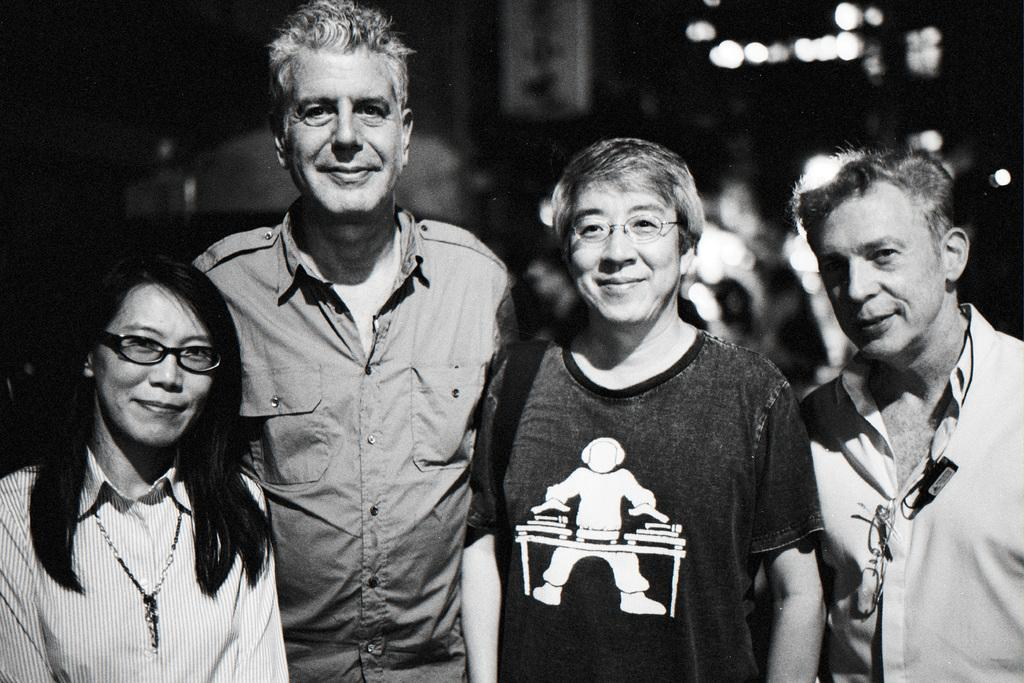What is the color scheme of the image? The image is black and white. How many men and women are in the image? There are two men and two women in the image. What are the people in the image doing? The people are standing. Can you describe the background of the image? The background is blurred. In which direction are the people in the image lifting the care? There is no car or lifting action present in the image; it features four people standing in a black and white setting with a blurred background. 